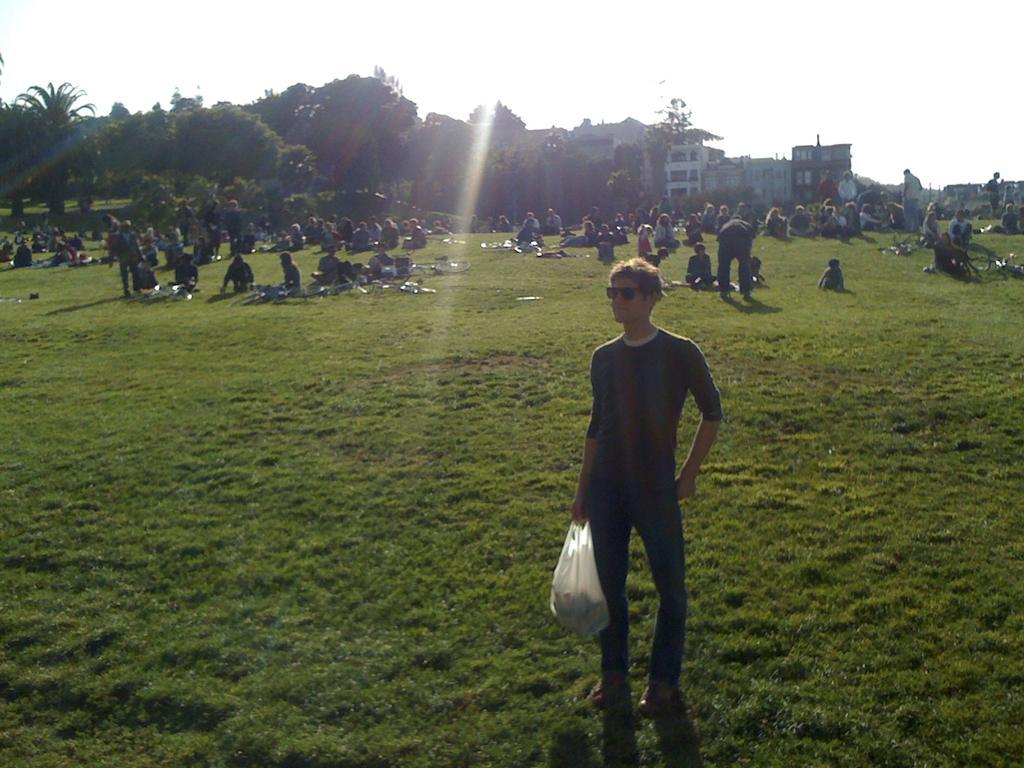Describe this image in one or two sentences. In this image I can see a man in front who is holding a cover in his hand and I see that he is standing. I can also see he is wearing shades. In the background number of people in which most of them are sitting and rest of them are standing and I see the trees, buildings and the sky and I can also see the grass. 